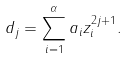Convert formula to latex. <formula><loc_0><loc_0><loc_500><loc_500>d _ { j } = \sum _ { i = 1 } ^ { \alpha } a _ { i } z _ { i } ^ { 2 j + 1 } .</formula> 